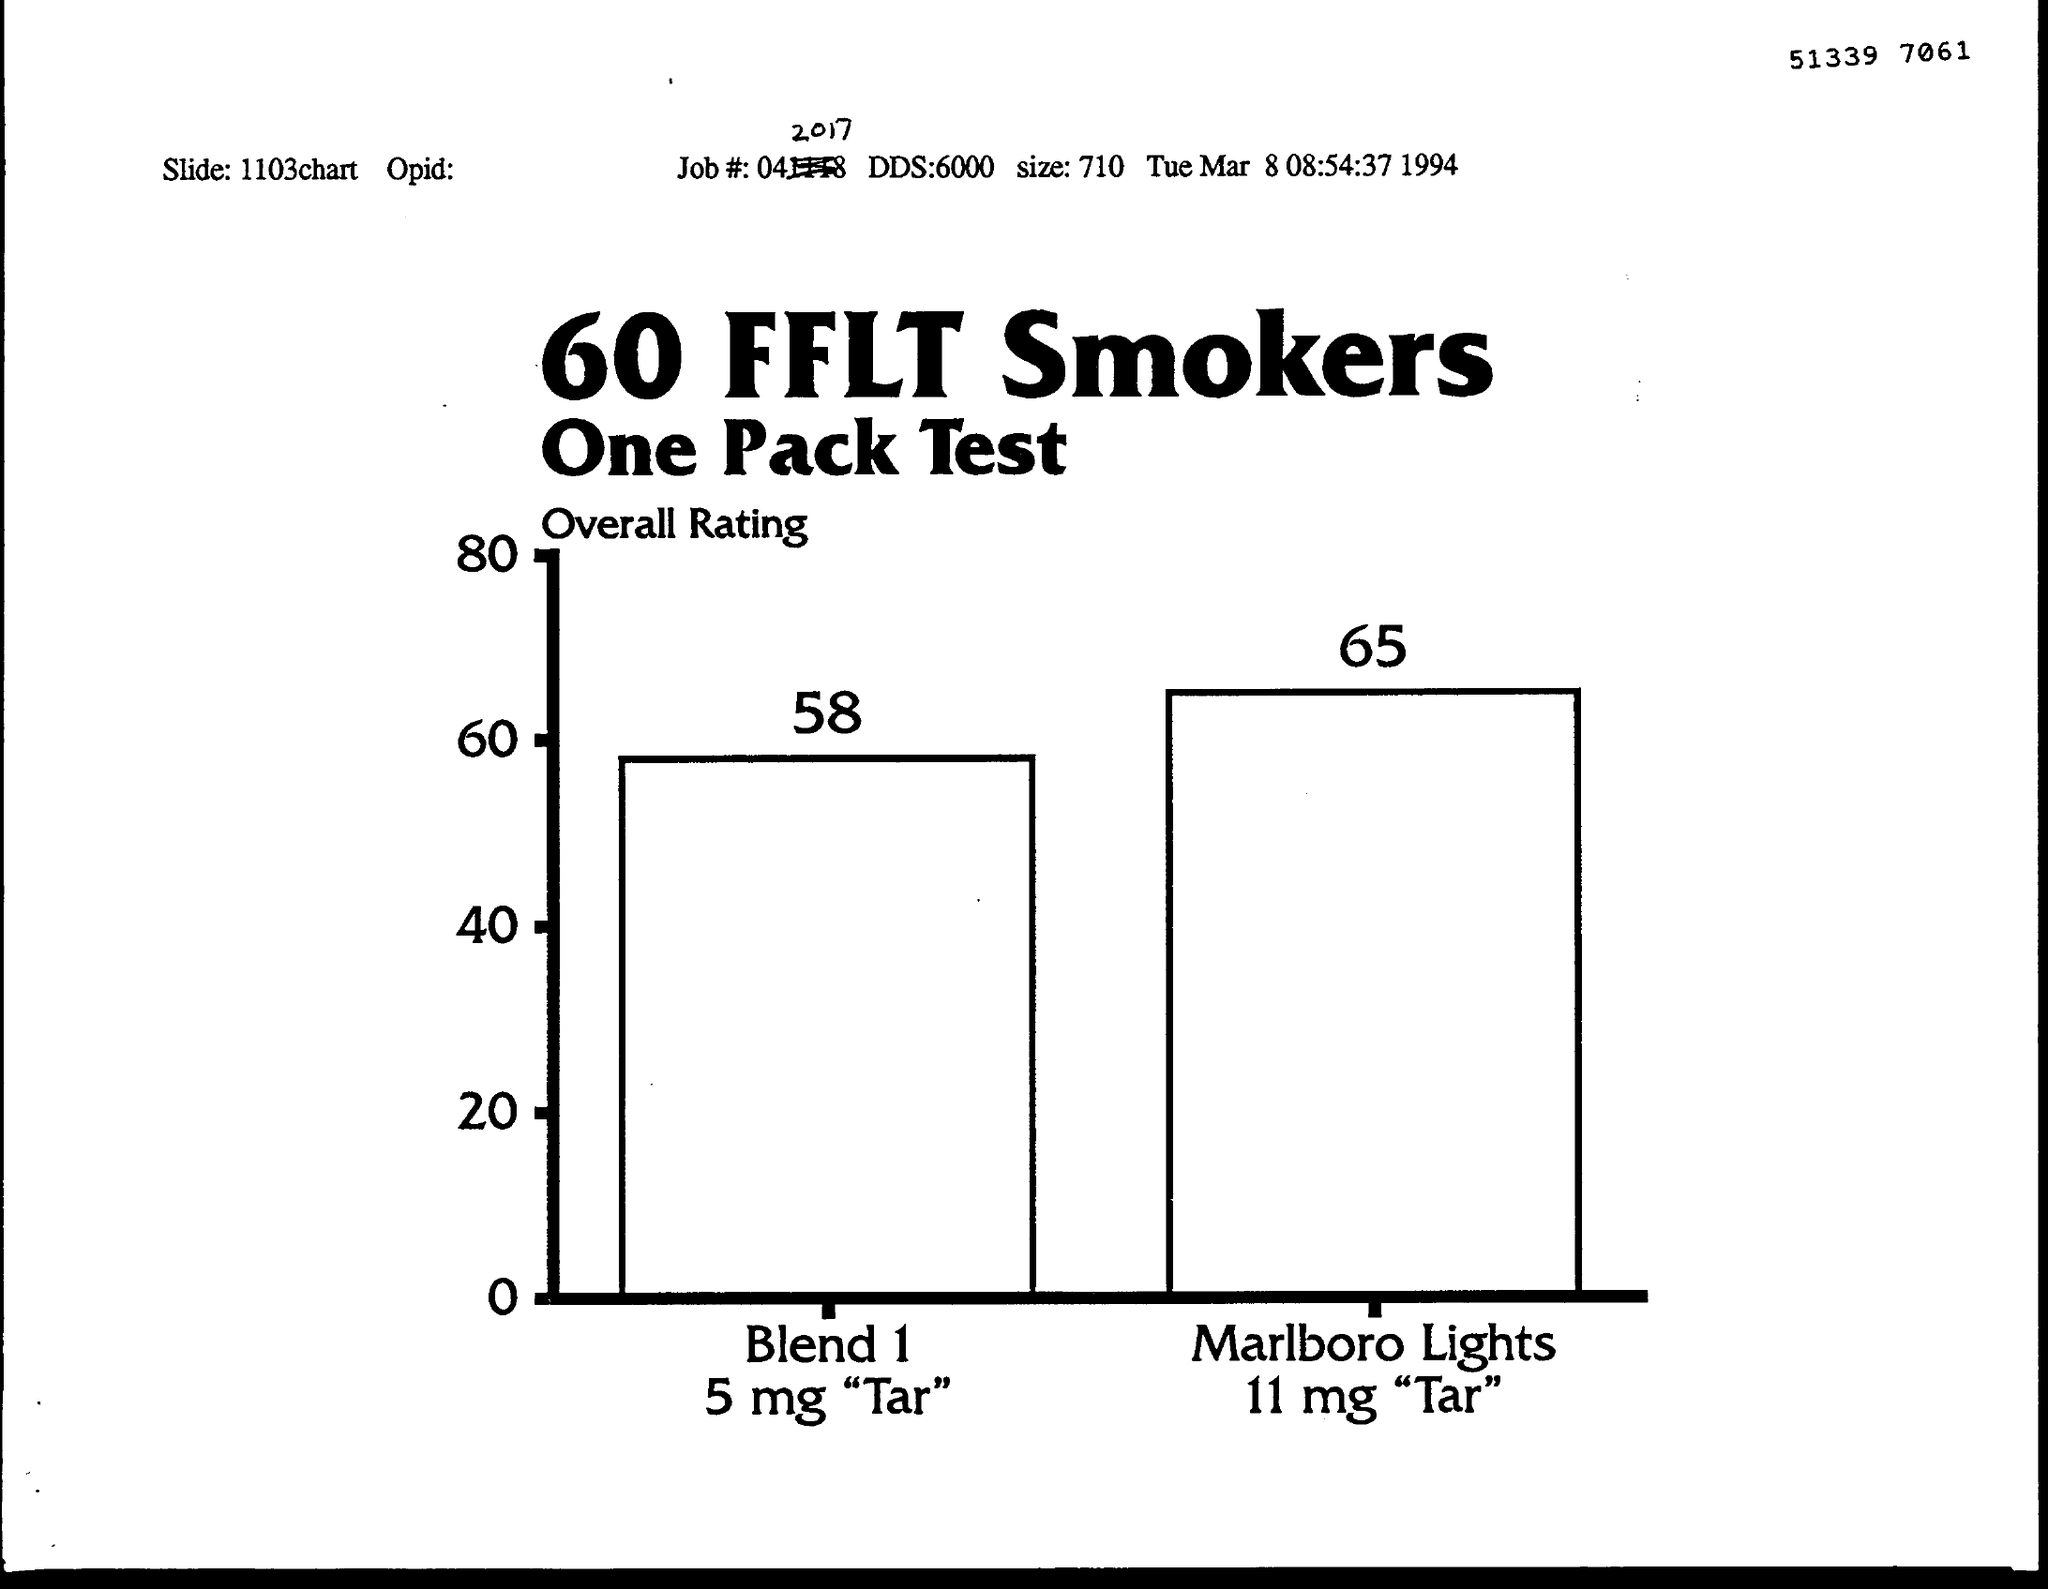What is the Job#?
Your answer should be compact. 04. What is the DDS?
Give a very brief answer. 6000. What is the size?
Your response must be concise. 710. 